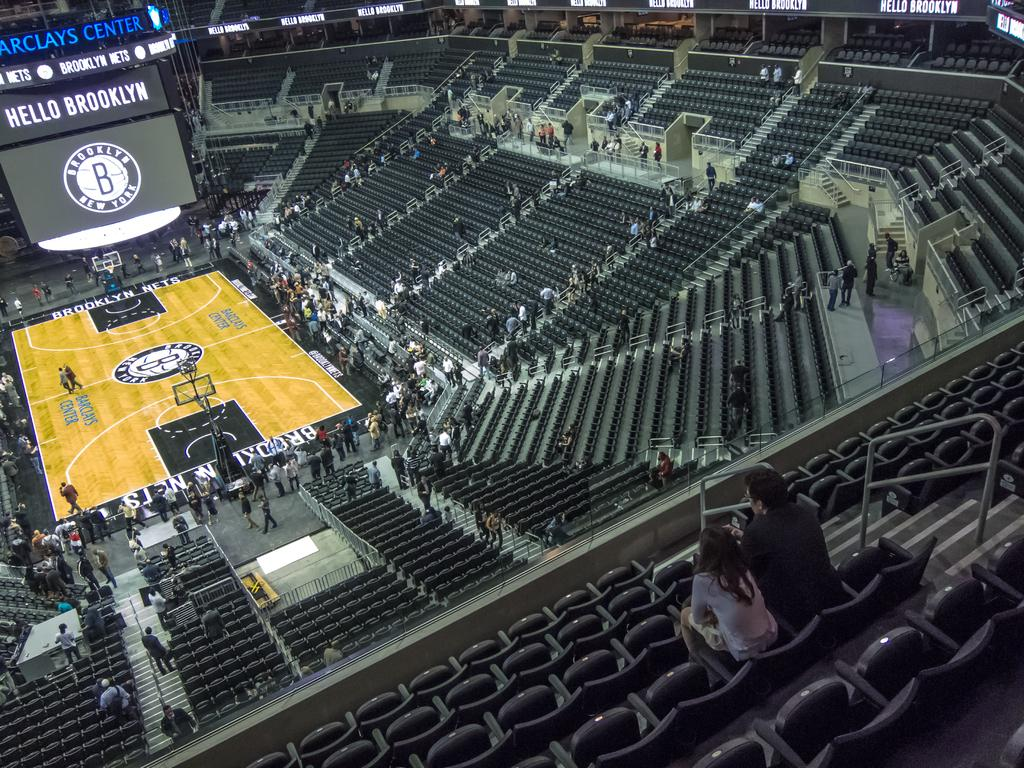<image>
Give a short and clear explanation of the subsequent image. Fans fill in the Barclays Center before a game. 